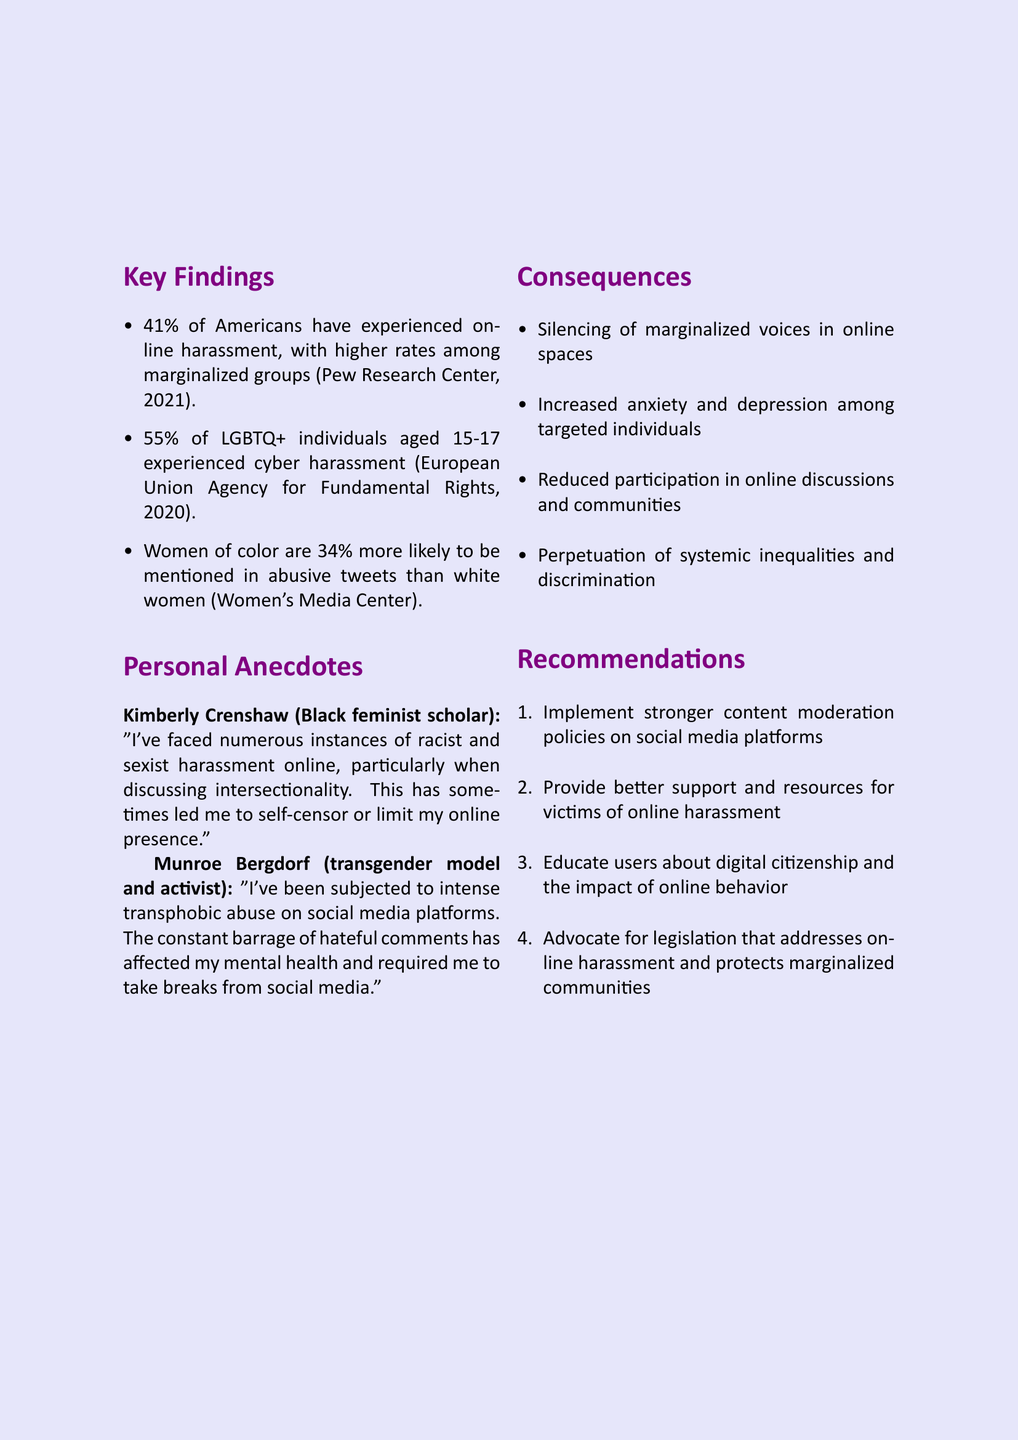What percentage of Americans have experienced online harassment? The statistic indicates that 41% of Americans have faced online harassment according to the Pew Research Center study in 2021.
Answer: 41% What is the percentage of LGBTQ+ individuals aged 15-17 who experience cyber harassment? The Europe Union Agency for Fundamental Rights reported that 55% of LGBTQ+ individuals aged 15-17 experienced cyber harassment.
Answer: 55% Who reported that women of color are 34% more likely to be mentioned in abusive tweets? The Women's Media Center provided this statistic regarding the likelihood of women of color facing abusive mentions online.
Answer: Women's Media Center What effect has online harassment had on Kimberly Crenshaw's online presence? Kimberly Crenshaw expressed that harassment led her to self-censor or limit her online presence.
Answer: Self-censor What are two consequences of online harassment mentioned in the document? The document lists multiple consequences, including "silencing of marginalized voices" and "increased anxiety and depression."
Answer: Silencing of marginalized voices; increased anxiety and depression What is one recommendation for addressing online harassment? The document suggests implementing stronger content moderation policies on social media platforms as a recommendation.
Answer: Stronger content moderation policies What year did the Pew Research Center conduct the study about online harassment? The study from the Pew Research Center regarding online harassment was conducted in 2021.
Answer: 2021 Who shared an experience of intense transphobic abuse on social media? Munroe Bergdorf shared her experience of facing intense transphobic abuse online.
Answer: Munroe Bergdorf 